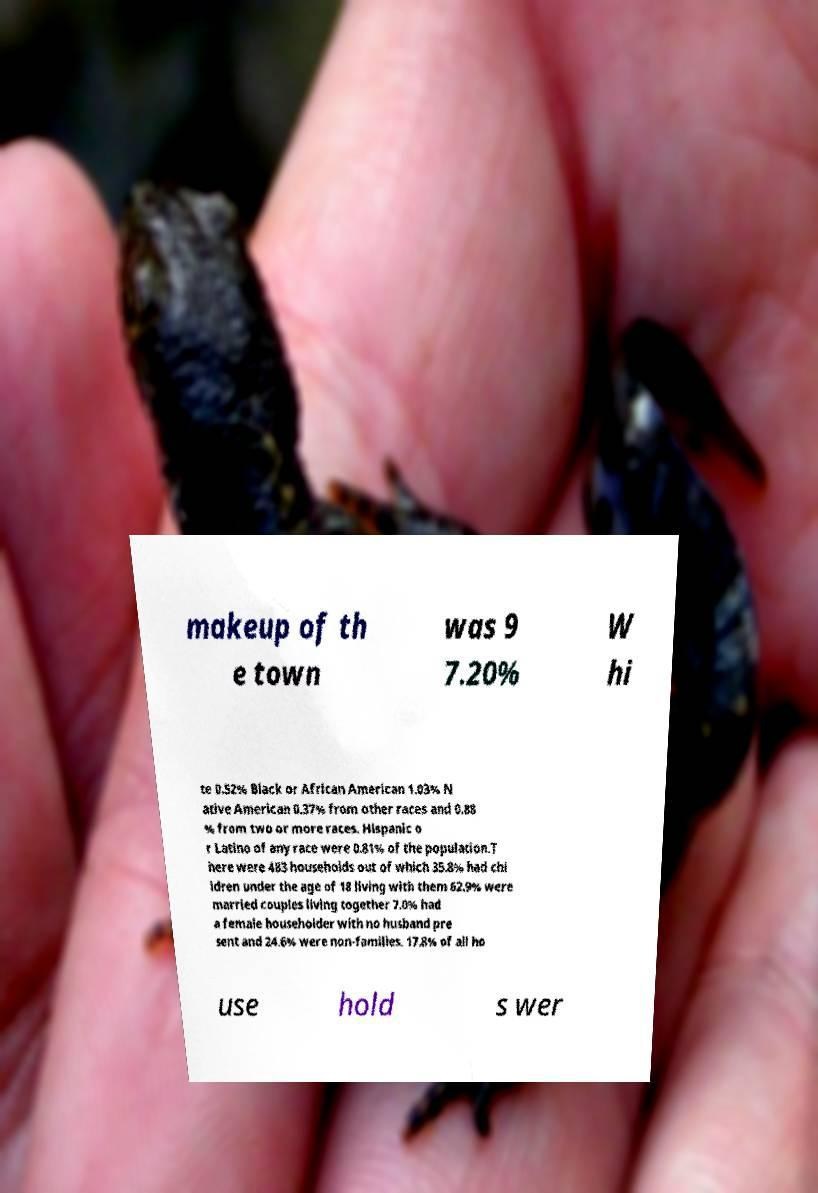Can you accurately transcribe the text from the provided image for me? makeup of th e town was 9 7.20% W hi te 0.52% Black or African American 1.03% N ative American 0.37% from other races and 0.88 % from two or more races. Hispanic o r Latino of any race were 0.81% of the population.T here were 483 households out of which 35.8% had chi ldren under the age of 18 living with them 62.9% were married couples living together 7.0% had a female householder with no husband pre sent and 24.6% were non-families. 17.8% of all ho use hold s wer 